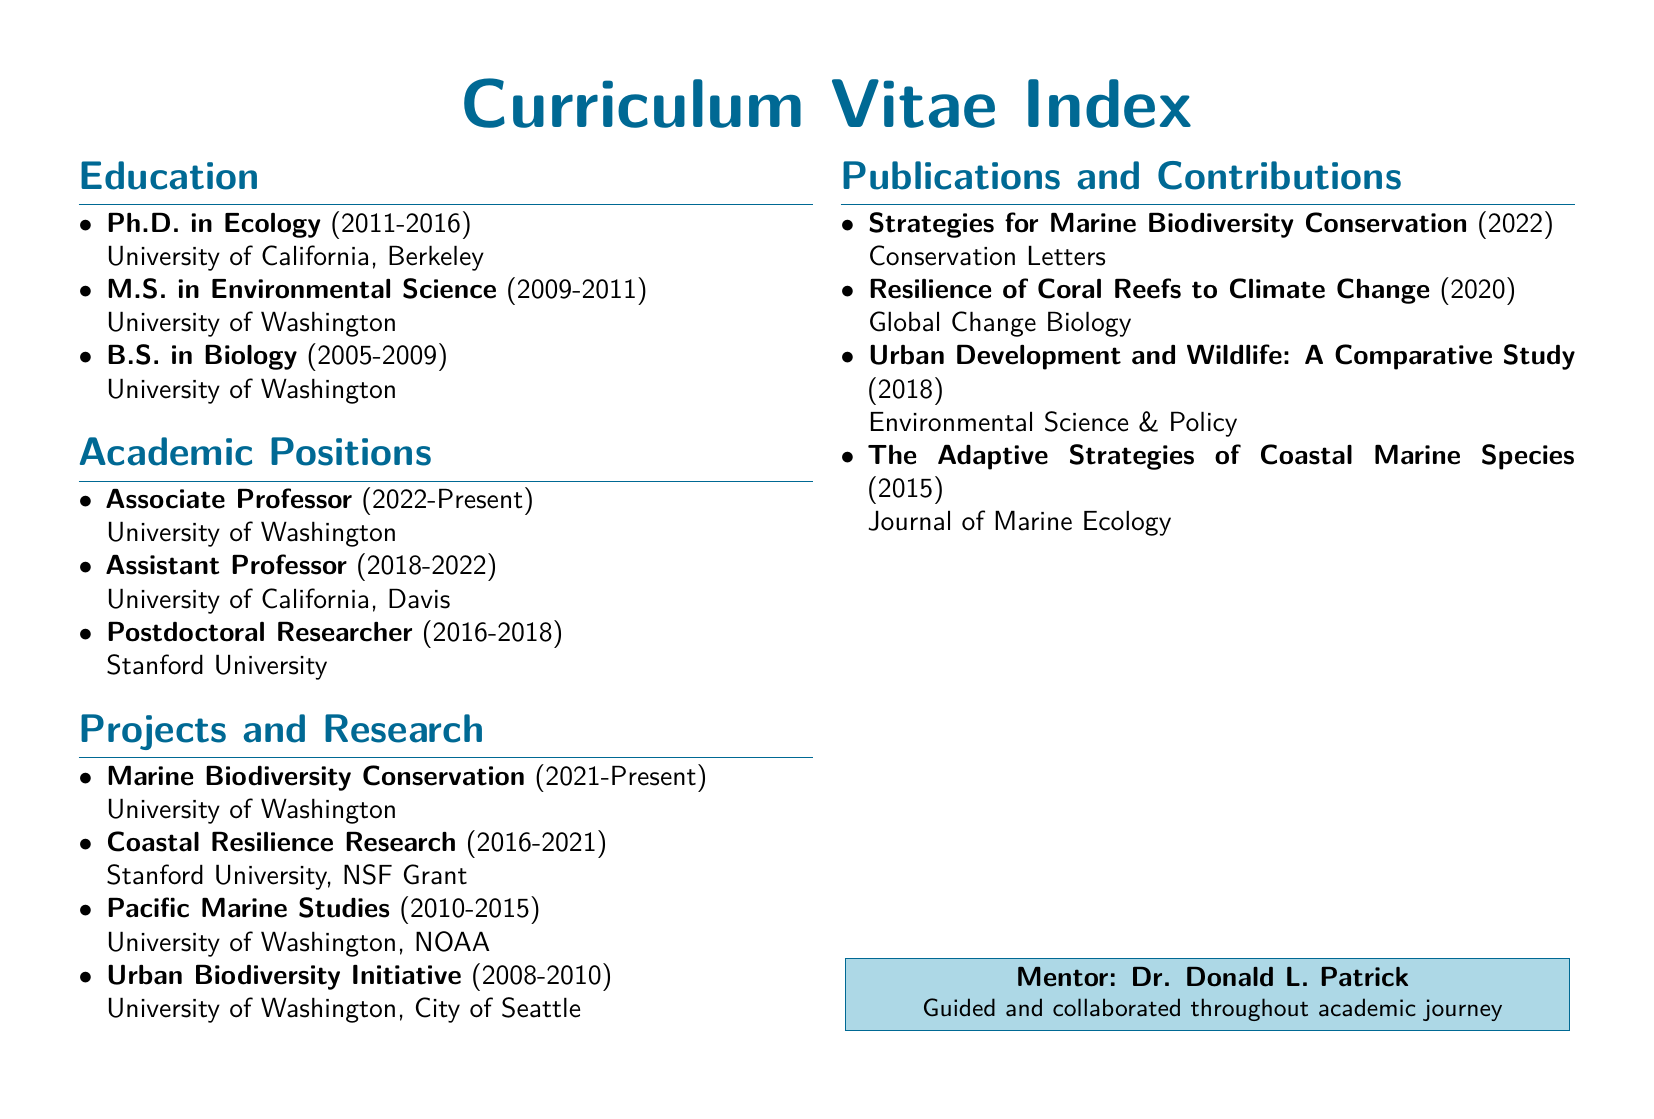What degree was obtained at the University of California, Berkeley? The document states that a Ph.D. in Ecology was obtained at the University of California, Berkeley.
Answer: Ph.D. in Ecology What position was held at Stanford University? The document lists the position of Postdoctoral Researcher as being held at Stanford University from 2016 to 2018.
Answer: Postdoctoral Researcher In what year did the Marine Biodiversity Conservation project begin? The document indicates that the Marine Biodiversity Conservation project started in 2021.
Answer: 2021 How many publications are listed in the document? The document includes four publications under the Publications and Contributions section.
Answer: Four Which educational institution did the M.S. degree come from? According to the document, the M.S. in Environmental Science was obtained from the University of Washington.
Answer: University of Washington What is the title of the publication from 2020? The document specifies "Resilience of Coral Reefs to Climate Change" as a publication from 2020.
Answer: Resilience of Coral Reefs to Climate Change What type of index is presented in this document? The document is identified as a Curriculum Vitae Index, detailing academic positions, projects, and advancements.
Answer: Curriculum Vitae Index Who mentored throughout the academic journey? The document notes Dr. Donald L. Patrick as the mentor throughout the academic journey.
Answer: Dr. Donald L. Patrick 